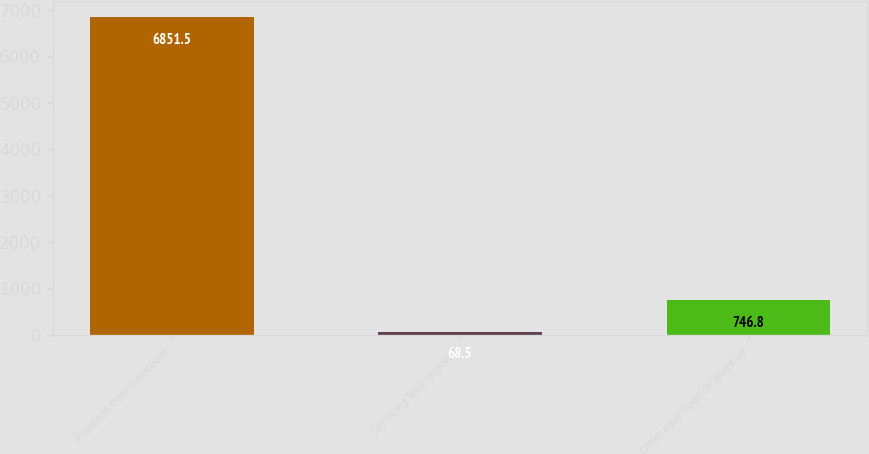Convert chart. <chart><loc_0><loc_0><loc_500><loc_500><bar_chart><fcel>Proceeds from collections<fcel>Servicing fees received<fcel>Other cash flows received on<nl><fcel>6851.5<fcel>68.5<fcel>746.8<nl></chart> 